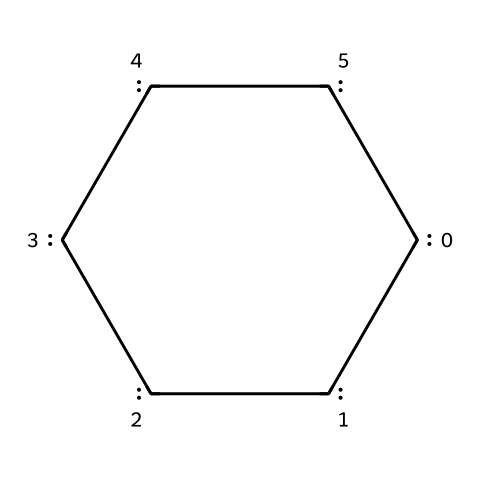What is the primary element present in this structure? The SMILES representation indicates that the structure consists of carbon atoms, as represented by the letter "C."
Answer: carbon How many carbon atoms are present in this molecule? By examining the SMILES notation, each "[C]" denotes a carbon atom, and there are six such instances in the structure.
Answer: six What type of bonding is primarily observed in this molecule? The structure includes alternating single and double bonds between carbon atoms, which is characteristic of aromatic compounds or conjugated systems.
Answer: aromatic Is this molecule likely to exhibit electrical conductivity? Graphene, being a form of carbon with a delocalized electron system due to its structure, is well-known for its high electrical conductivity.
Answer: yes What is a potential application of this nanomaterial in astronomy? Due to its ultra-sensitive nature, graphene can be used in detectors to measure weak signals, which is especially important in the study of LSB galaxies.
Answer: detectors Which property of this nanomaterial enhances its sensitivity? The high surface area and conductivity of graphene contribute to its sensitivity, allowing it to respond to minute changes in its environment.
Answer: high surface area 